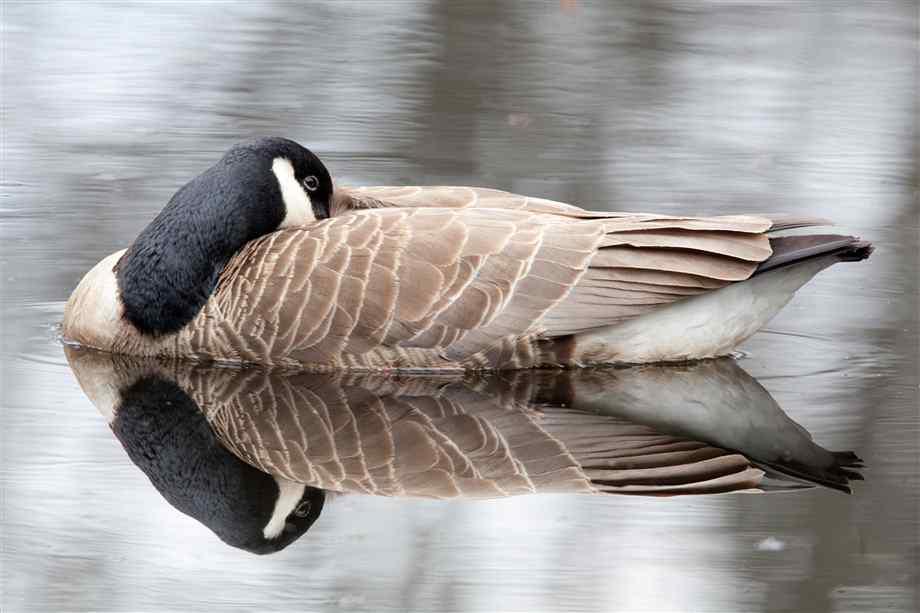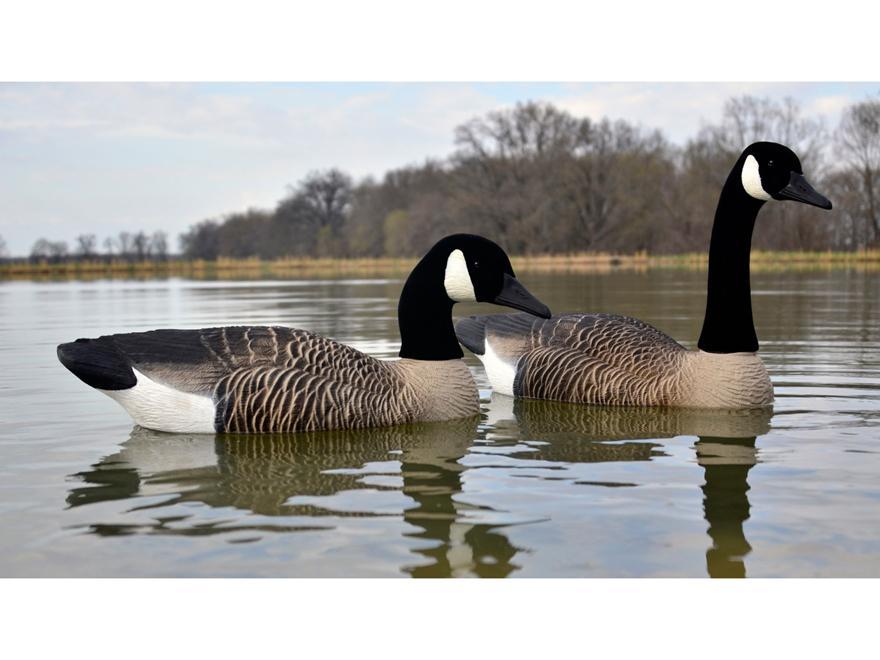The first image is the image on the left, the second image is the image on the right. For the images displayed, is the sentence "The bird in the image on the right is sitting in the grass." factually correct? Answer yes or no. No. 